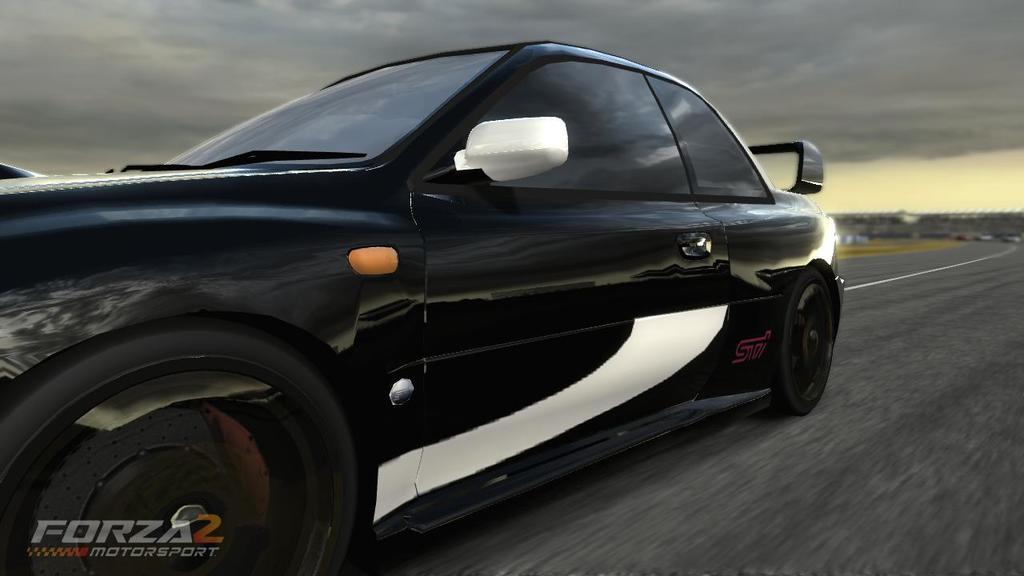What is the main subject in the center of the image? There is a car in the center of the image. What is located at the bottom of the image? There is a road at the bottom of the image. What type of vegetation can be seen in the background of the image? There is grass in the background of the image. What is visible at the top of the image? The sky is visible at the top of the image. What is the title of the story being told by the car in the image? There is no story being told by the car in the image, and therefore no title can be assigned. 